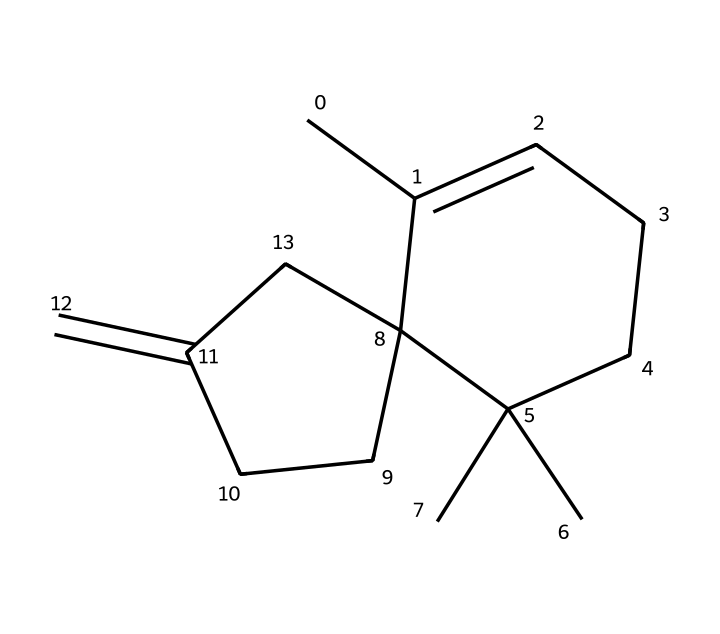What is the molecular formula of caryophyllene? To determine the molecular formula, we count the number of each type of atom in the chemical structure. The chemical has 15 carbon atoms and 24 hydrogen atoms, leading to the formula C15H24.
Answer: C15H24 How many double bonds are present in the structure? By analyzing the structure, we see one occurrence of a double bond in the form of a carbon-carbon bond. This indicates that there is one double bond in caryophyllene.
Answer: 1 What type of compound is caryophyllene classified as? Caryophyllene is recognized as a terpene based on its chemical structure, characterized by multiple carbon atoms arranged in connected rings. Additionally, its specific classification can be derived from its presence as a natural substance in various plants.
Answer: terpene What kind of cyclic structure is present in caryophyllene? Observing the structure indicates the presence of a bicyclic compound, which means it contains two fused rings. This specific arrangement is crucial for its properties as a terpene.
Answer: bicyclic What is the significance of caryophyllene in drug detection? Caryophyllene's unique aromatic profile and volatility make it useful for training drug-sniffing dogs, as it serves to mimic certain drug scents which helps enhance the dogs' detection abilities through familiarization with this compound.
Answer: scent mimicry 